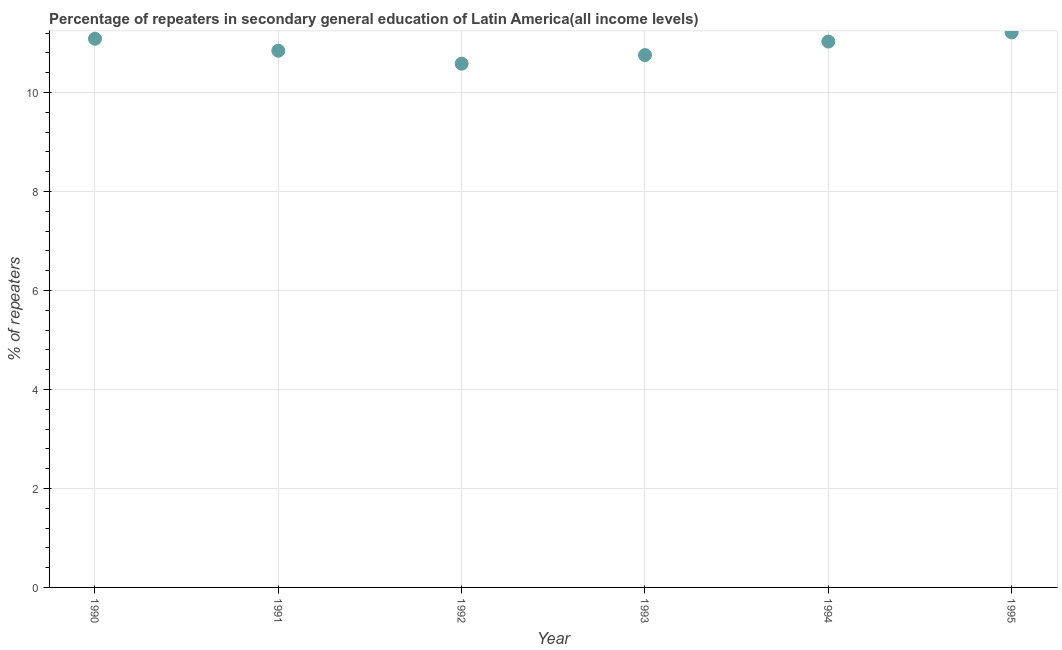What is the percentage of repeaters in 1995?
Your answer should be compact. 11.21. Across all years, what is the maximum percentage of repeaters?
Your response must be concise. 11.21. Across all years, what is the minimum percentage of repeaters?
Provide a short and direct response. 10.58. In which year was the percentage of repeaters maximum?
Provide a succinct answer. 1995. What is the sum of the percentage of repeaters?
Your response must be concise. 65.51. What is the difference between the percentage of repeaters in 1992 and 1994?
Offer a terse response. -0.45. What is the average percentage of repeaters per year?
Keep it short and to the point. 10.92. What is the median percentage of repeaters?
Your answer should be compact. 10.94. Do a majority of the years between 1992 and 1994 (inclusive) have percentage of repeaters greater than 2.8 %?
Provide a short and direct response. Yes. What is the ratio of the percentage of repeaters in 1993 to that in 1995?
Your answer should be compact. 0.96. Is the percentage of repeaters in 1992 less than that in 1995?
Provide a succinct answer. Yes. Is the difference between the percentage of repeaters in 1993 and 1995 greater than the difference between any two years?
Make the answer very short. No. What is the difference between the highest and the second highest percentage of repeaters?
Your answer should be compact. 0.13. Is the sum of the percentage of repeaters in 1992 and 1993 greater than the maximum percentage of repeaters across all years?
Provide a short and direct response. Yes. What is the difference between the highest and the lowest percentage of repeaters?
Offer a terse response. 0.63. What is the difference between two consecutive major ticks on the Y-axis?
Your response must be concise. 2. What is the title of the graph?
Keep it short and to the point. Percentage of repeaters in secondary general education of Latin America(all income levels). What is the label or title of the Y-axis?
Your answer should be compact. % of repeaters. What is the % of repeaters in 1990?
Keep it short and to the point. 11.09. What is the % of repeaters in 1991?
Provide a short and direct response. 10.84. What is the % of repeaters in 1992?
Keep it short and to the point. 10.58. What is the % of repeaters in 1993?
Give a very brief answer. 10.76. What is the % of repeaters in 1994?
Offer a terse response. 11.03. What is the % of repeaters in 1995?
Make the answer very short. 11.21. What is the difference between the % of repeaters in 1990 and 1991?
Make the answer very short. 0.24. What is the difference between the % of repeaters in 1990 and 1992?
Provide a short and direct response. 0.5. What is the difference between the % of repeaters in 1990 and 1993?
Your answer should be compact. 0.33. What is the difference between the % of repeaters in 1990 and 1994?
Ensure brevity in your answer.  0.06. What is the difference between the % of repeaters in 1990 and 1995?
Provide a short and direct response. -0.13. What is the difference between the % of repeaters in 1991 and 1992?
Offer a terse response. 0.26. What is the difference between the % of repeaters in 1991 and 1993?
Ensure brevity in your answer.  0.09. What is the difference between the % of repeaters in 1991 and 1994?
Your answer should be compact. -0.19. What is the difference between the % of repeaters in 1991 and 1995?
Your answer should be compact. -0.37. What is the difference between the % of repeaters in 1992 and 1993?
Offer a very short reply. -0.17. What is the difference between the % of repeaters in 1992 and 1994?
Ensure brevity in your answer.  -0.45. What is the difference between the % of repeaters in 1992 and 1995?
Your answer should be very brief. -0.63. What is the difference between the % of repeaters in 1993 and 1994?
Your answer should be compact. -0.27. What is the difference between the % of repeaters in 1993 and 1995?
Ensure brevity in your answer.  -0.46. What is the difference between the % of repeaters in 1994 and 1995?
Your answer should be very brief. -0.19. What is the ratio of the % of repeaters in 1990 to that in 1991?
Offer a terse response. 1.02. What is the ratio of the % of repeaters in 1990 to that in 1992?
Ensure brevity in your answer.  1.05. What is the ratio of the % of repeaters in 1990 to that in 1993?
Ensure brevity in your answer.  1.03. What is the ratio of the % of repeaters in 1990 to that in 1994?
Ensure brevity in your answer.  1. What is the ratio of the % of repeaters in 1990 to that in 1995?
Your answer should be compact. 0.99. What is the ratio of the % of repeaters in 1991 to that in 1992?
Your response must be concise. 1.02. What is the ratio of the % of repeaters in 1991 to that in 1994?
Provide a succinct answer. 0.98. What is the ratio of the % of repeaters in 1992 to that in 1993?
Offer a terse response. 0.98. What is the ratio of the % of repeaters in 1992 to that in 1994?
Offer a very short reply. 0.96. What is the ratio of the % of repeaters in 1992 to that in 1995?
Your answer should be compact. 0.94. What is the ratio of the % of repeaters in 1994 to that in 1995?
Give a very brief answer. 0.98. 